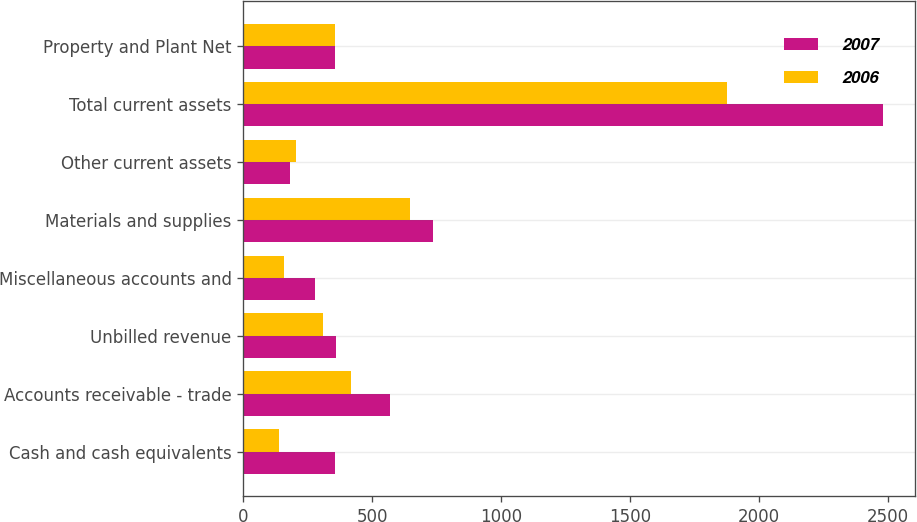Convert chart to OTSL. <chart><loc_0><loc_0><loc_500><loc_500><stacked_bar_chart><ecel><fcel>Cash and cash equivalents<fcel>Accounts receivable - trade<fcel>Unbilled revenue<fcel>Miscellaneous accounts and<fcel>Materials and supplies<fcel>Other current assets<fcel>Total current assets<fcel>Property and Plant Net<nl><fcel>2007<fcel>355<fcel>570<fcel>359<fcel>280<fcel>735<fcel>181<fcel>2480<fcel>357<nl><fcel>2006<fcel>137<fcel>418<fcel>309<fcel>160<fcel>647<fcel>203<fcel>1874<fcel>357<nl></chart> 